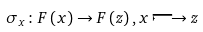Convert formula to latex. <formula><loc_0><loc_0><loc_500><loc_500>\sigma _ { x } \colon F \left ( x \right ) \rightarrow F \left ( z \right ) , x \longmapsto z</formula> 